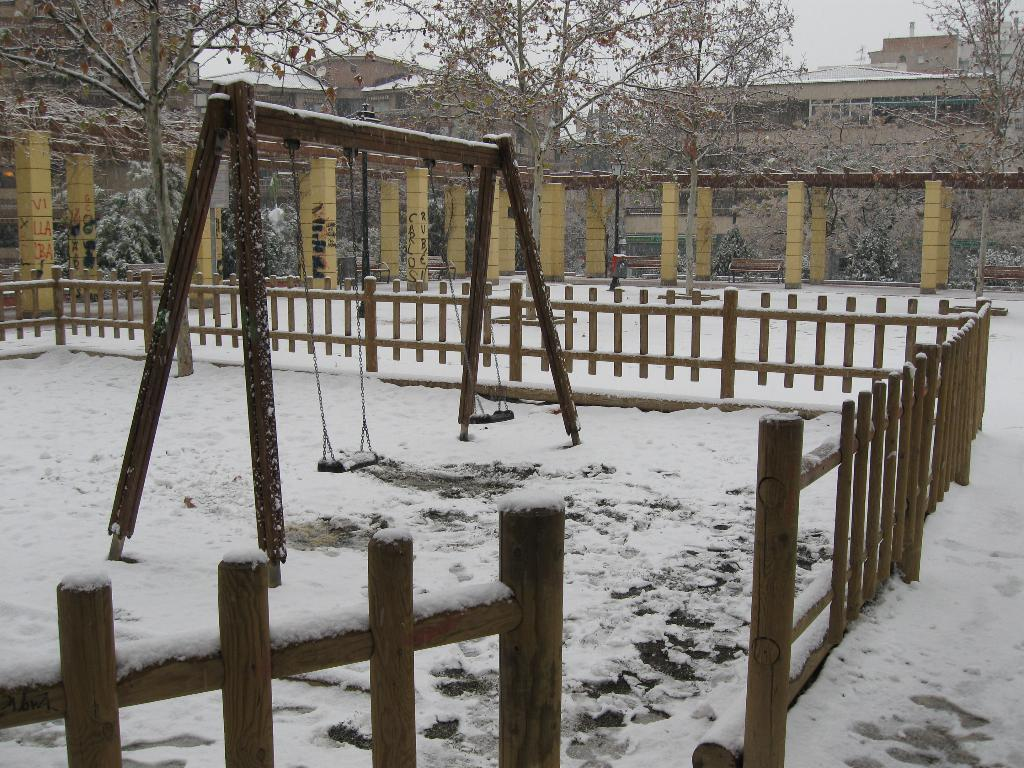What is the main object in the image? There is a swing in the image. What is the weather like in the image? There is snow in the image, indicating a cold and wintry scene. What type of structure can be seen in the image? There is fencing, trees, pillars, and a building visible in the image. What is visible in the background of the image? The sky is visible in the image. What language is being spoken by the people in the image? There are no people visible in the image, so it is impossible to determine what language they might be speaking. Can you tell me how many gravestones are present in the image? There is no cemetery or gravestones present in the image; it features a swing, snow, and various structures. 